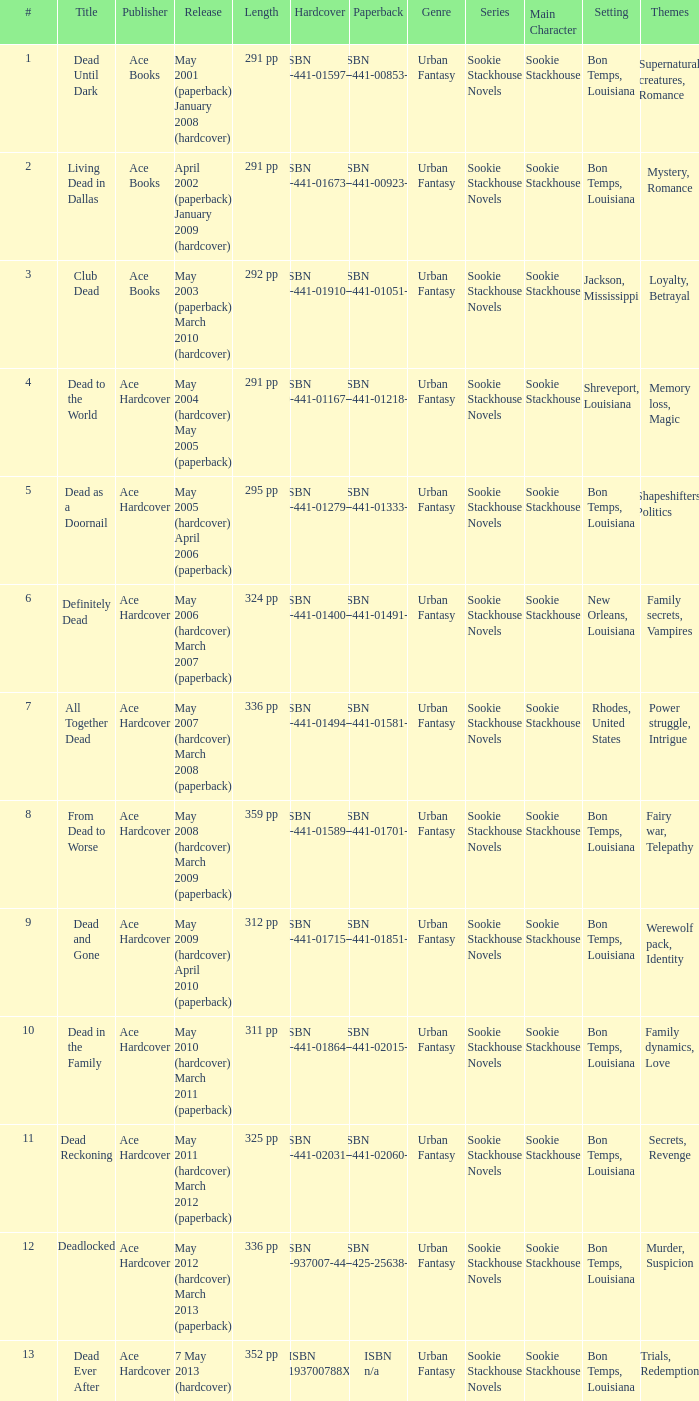Isbn 0-441-01400-3 is book number? 6.0. 